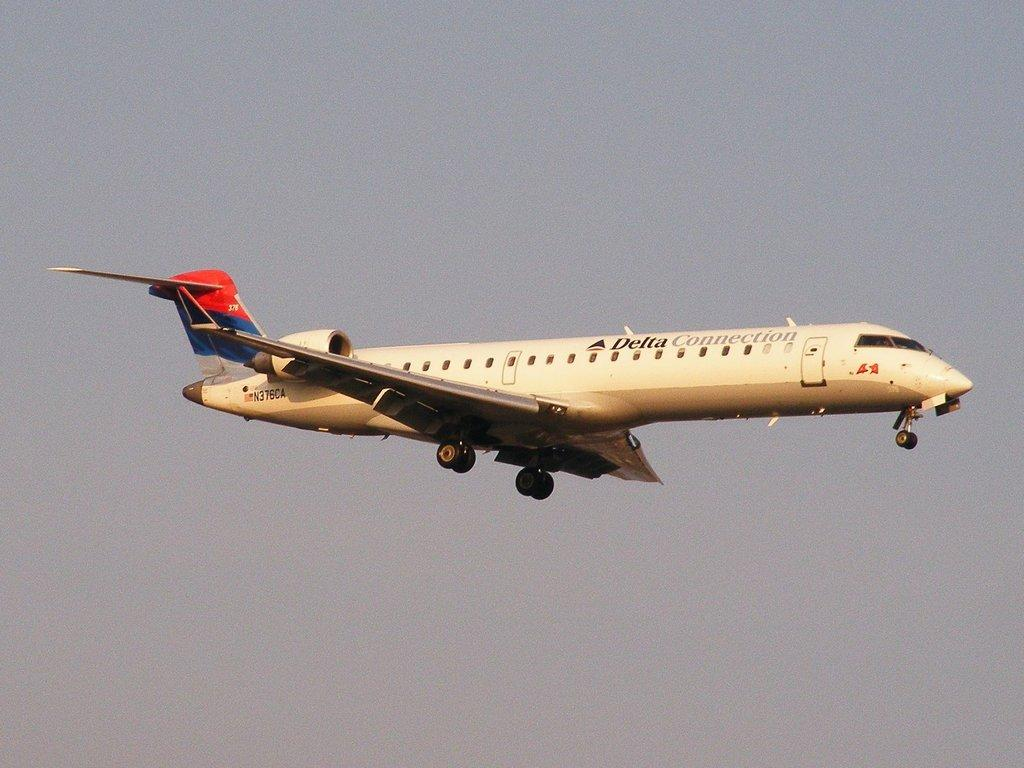<image>
Share a concise interpretation of the image provided. An airplane with its landing gear down that is labeled Delta Connections. 